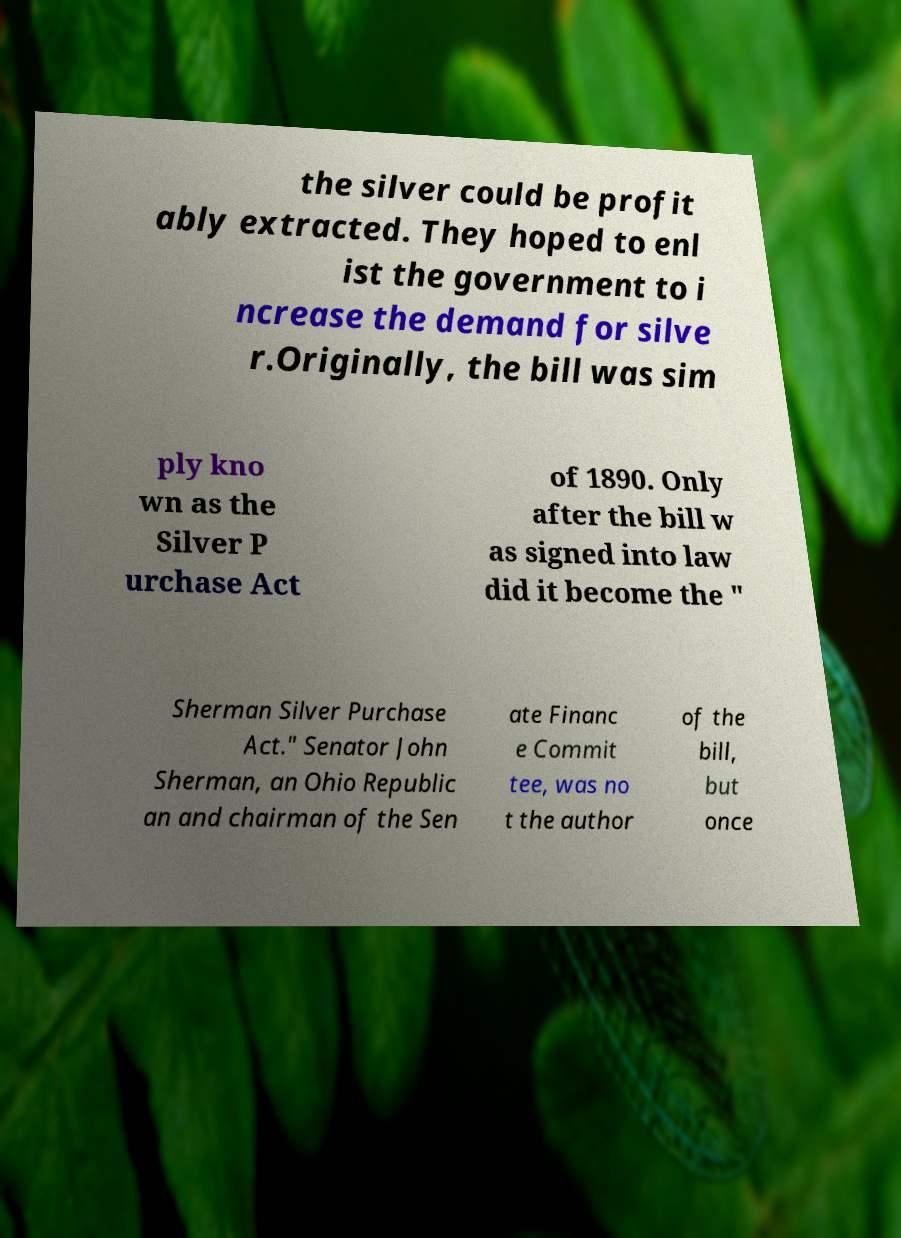Please read and relay the text visible in this image. What does it say? the silver could be profit ably extracted. They hoped to enl ist the government to i ncrease the demand for silve r.Originally, the bill was sim ply kno wn as the Silver P urchase Act of 1890. Only after the bill w as signed into law did it become the " Sherman Silver Purchase Act." Senator John Sherman, an Ohio Republic an and chairman of the Sen ate Financ e Commit tee, was no t the author of the bill, but once 